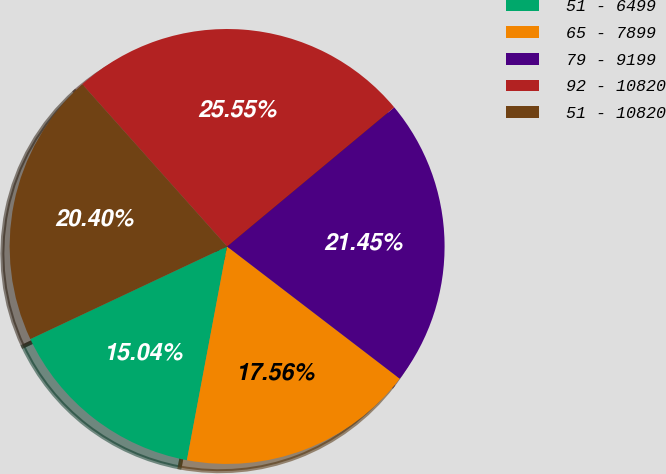Convert chart. <chart><loc_0><loc_0><loc_500><loc_500><pie_chart><fcel>51 - 6499<fcel>65 - 7899<fcel>79 - 9199<fcel>92 - 10820<fcel>51 - 10820<nl><fcel>15.04%<fcel>17.56%<fcel>21.45%<fcel>25.55%<fcel>20.4%<nl></chart> 